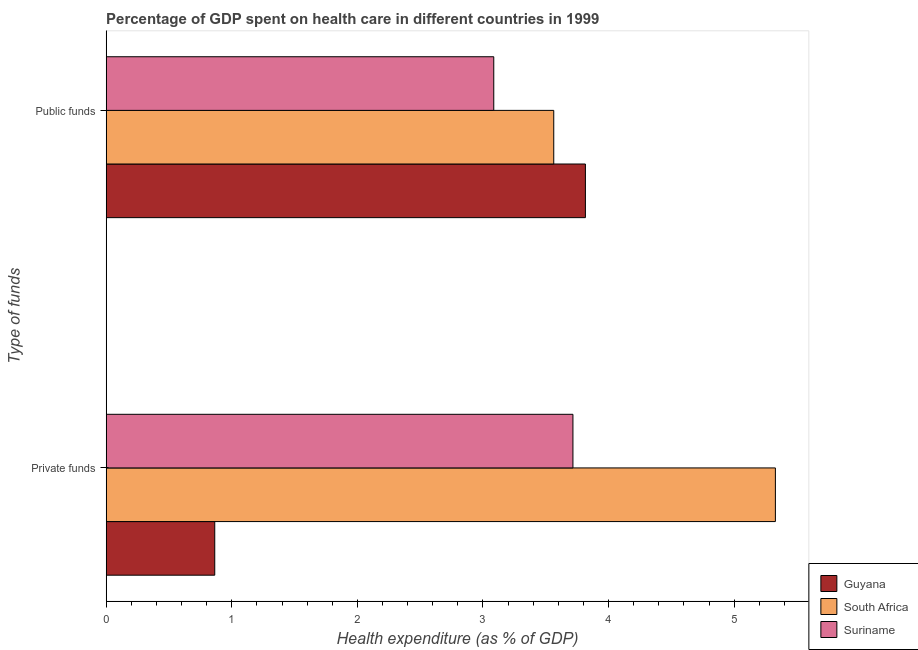How many groups of bars are there?
Your answer should be very brief. 2. Are the number of bars on each tick of the Y-axis equal?
Give a very brief answer. Yes. What is the label of the 1st group of bars from the top?
Your answer should be compact. Public funds. What is the amount of private funds spent in healthcare in South Africa?
Give a very brief answer. 5.33. Across all countries, what is the maximum amount of public funds spent in healthcare?
Your answer should be compact. 3.82. Across all countries, what is the minimum amount of private funds spent in healthcare?
Keep it short and to the point. 0.86. In which country was the amount of public funds spent in healthcare maximum?
Ensure brevity in your answer.  Guyana. In which country was the amount of private funds spent in healthcare minimum?
Make the answer very short. Guyana. What is the total amount of private funds spent in healthcare in the graph?
Offer a very short reply. 9.91. What is the difference between the amount of private funds spent in healthcare in South Africa and that in Guyana?
Provide a short and direct response. 4.46. What is the difference between the amount of private funds spent in healthcare in Suriname and the amount of public funds spent in healthcare in South Africa?
Ensure brevity in your answer.  0.15. What is the average amount of public funds spent in healthcare per country?
Give a very brief answer. 3.49. What is the difference between the amount of public funds spent in healthcare and amount of private funds spent in healthcare in South Africa?
Keep it short and to the point. -1.76. What is the ratio of the amount of public funds spent in healthcare in Suriname to that in Guyana?
Keep it short and to the point. 0.81. In how many countries, is the amount of public funds spent in healthcare greater than the average amount of public funds spent in healthcare taken over all countries?
Ensure brevity in your answer.  2. What does the 3rd bar from the top in Public funds represents?
Offer a very short reply. Guyana. What does the 1st bar from the bottom in Public funds represents?
Make the answer very short. Guyana. How many bars are there?
Your response must be concise. 6. Are all the bars in the graph horizontal?
Make the answer very short. Yes. How many countries are there in the graph?
Make the answer very short. 3. Does the graph contain any zero values?
Offer a very short reply. No. Does the graph contain grids?
Offer a terse response. No. Where does the legend appear in the graph?
Your answer should be compact. Bottom right. How many legend labels are there?
Your answer should be very brief. 3. How are the legend labels stacked?
Offer a terse response. Vertical. What is the title of the graph?
Keep it short and to the point. Percentage of GDP spent on health care in different countries in 1999. Does "Thailand" appear as one of the legend labels in the graph?
Ensure brevity in your answer.  No. What is the label or title of the X-axis?
Offer a terse response. Health expenditure (as % of GDP). What is the label or title of the Y-axis?
Give a very brief answer. Type of funds. What is the Health expenditure (as % of GDP) in Guyana in Private funds?
Make the answer very short. 0.86. What is the Health expenditure (as % of GDP) in South Africa in Private funds?
Your response must be concise. 5.33. What is the Health expenditure (as % of GDP) of Suriname in Private funds?
Your answer should be compact. 3.72. What is the Health expenditure (as % of GDP) in Guyana in Public funds?
Provide a short and direct response. 3.82. What is the Health expenditure (as % of GDP) of South Africa in Public funds?
Your answer should be very brief. 3.56. What is the Health expenditure (as % of GDP) in Suriname in Public funds?
Ensure brevity in your answer.  3.09. Across all Type of funds, what is the maximum Health expenditure (as % of GDP) of Guyana?
Make the answer very short. 3.82. Across all Type of funds, what is the maximum Health expenditure (as % of GDP) in South Africa?
Make the answer very short. 5.33. Across all Type of funds, what is the maximum Health expenditure (as % of GDP) of Suriname?
Keep it short and to the point. 3.72. Across all Type of funds, what is the minimum Health expenditure (as % of GDP) of Guyana?
Your answer should be very brief. 0.86. Across all Type of funds, what is the minimum Health expenditure (as % of GDP) of South Africa?
Provide a succinct answer. 3.56. Across all Type of funds, what is the minimum Health expenditure (as % of GDP) in Suriname?
Provide a succinct answer. 3.09. What is the total Health expenditure (as % of GDP) of Guyana in the graph?
Ensure brevity in your answer.  4.68. What is the total Health expenditure (as % of GDP) of South Africa in the graph?
Your answer should be compact. 8.89. What is the total Health expenditure (as % of GDP) of Suriname in the graph?
Provide a short and direct response. 6.8. What is the difference between the Health expenditure (as % of GDP) in Guyana in Private funds and that in Public funds?
Offer a terse response. -2.95. What is the difference between the Health expenditure (as % of GDP) of South Africa in Private funds and that in Public funds?
Ensure brevity in your answer.  1.76. What is the difference between the Health expenditure (as % of GDP) in Suriname in Private funds and that in Public funds?
Your answer should be compact. 0.63. What is the difference between the Health expenditure (as % of GDP) in Guyana in Private funds and the Health expenditure (as % of GDP) in South Africa in Public funds?
Ensure brevity in your answer.  -2.7. What is the difference between the Health expenditure (as % of GDP) in Guyana in Private funds and the Health expenditure (as % of GDP) in Suriname in Public funds?
Your answer should be very brief. -2.22. What is the difference between the Health expenditure (as % of GDP) of South Africa in Private funds and the Health expenditure (as % of GDP) of Suriname in Public funds?
Your response must be concise. 2.24. What is the average Health expenditure (as % of GDP) of Guyana per Type of funds?
Provide a succinct answer. 2.34. What is the average Health expenditure (as % of GDP) of South Africa per Type of funds?
Your answer should be compact. 4.45. What is the average Health expenditure (as % of GDP) of Suriname per Type of funds?
Your answer should be compact. 3.4. What is the difference between the Health expenditure (as % of GDP) of Guyana and Health expenditure (as % of GDP) of South Africa in Private funds?
Make the answer very short. -4.46. What is the difference between the Health expenditure (as % of GDP) in Guyana and Health expenditure (as % of GDP) in Suriname in Private funds?
Provide a short and direct response. -2.85. What is the difference between the Health expenditure (as % of GDP) of South Africa and Health expenditure (as % of GDP) of Suriname in Private funds?
Offer a terse response. 1.61. What is the difference between the Health expenditure (as % of GDP) in Guyana and Health expenditure (as % of GDP) in South Africa in Public funds?
Keep it short and to the point. 0.25. What is the difference between the Health expenditure (as % of GDP) in Guyana and Health expenditure (as % of GDP) in Suriname in Public funds?
Your answer should be very brief. 0.73. What is the difference between the Health expenditure (as % of GDP) of South Africa and Health expenditure (as % of GDP) of Suriname in Public funds?
Give a very brief answer. 0.48. What is the ratio of the Health expenditure (as % of GDP) of Guyana in Private funds to that in Public funds?
Your answer should be compact. 0.23. What is the ratio of the Health expenditure (as % of GDP) in South Africa in Private funds to that in Public funds?
Your response must be concise. 1.5. What is the ratio of the Health expenditure (as % of GDP) in Suriname in Private funds to that in Public funds?
Keep it short and to the point. 1.2. What is the difference between the highest and the second highest Health expenditure (as % of GDP) in Guyana?
Give a very brief answer. 2.95. What is the difference between the highest and the second highest Health expenditure (as % of GDP) in South Africa?
Offer a very short reply. 1.76. What is the difference between the highest and the second highest Health expenditure (as % of GDP) of Suriname?
Provide a succinct answer. 0.63. What is the difference between the highest and the lowest Health expenditure (as % of GDP) of Guyana?
Keep it short and to the point. 2.95. What is the difference between the highest and the lowest Health expenditure (as % of GDP) of South Africa?
Give a very brief answer. 1.76. What is the difference between the highest and the lowest Health expenditure (as % of GDP) in Suriname?
Ensure brevity in your answer.  0.63. 